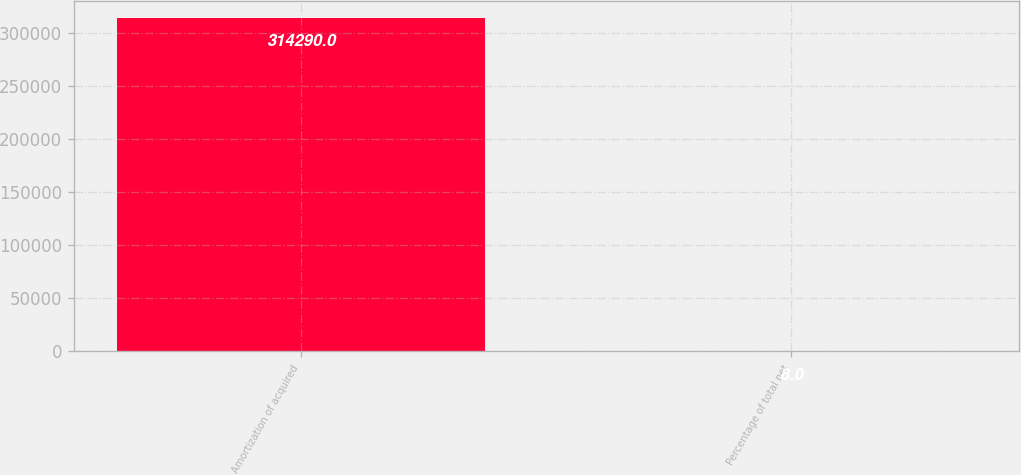Convert chart to OTSL. <chart><loc_0><loc_0><loc_500><loc_500><bar_chart><fcel>Amortization of acquired<fcel>Percentage of total net<nl><fcel>314290<fcel>8<nl></chart> 